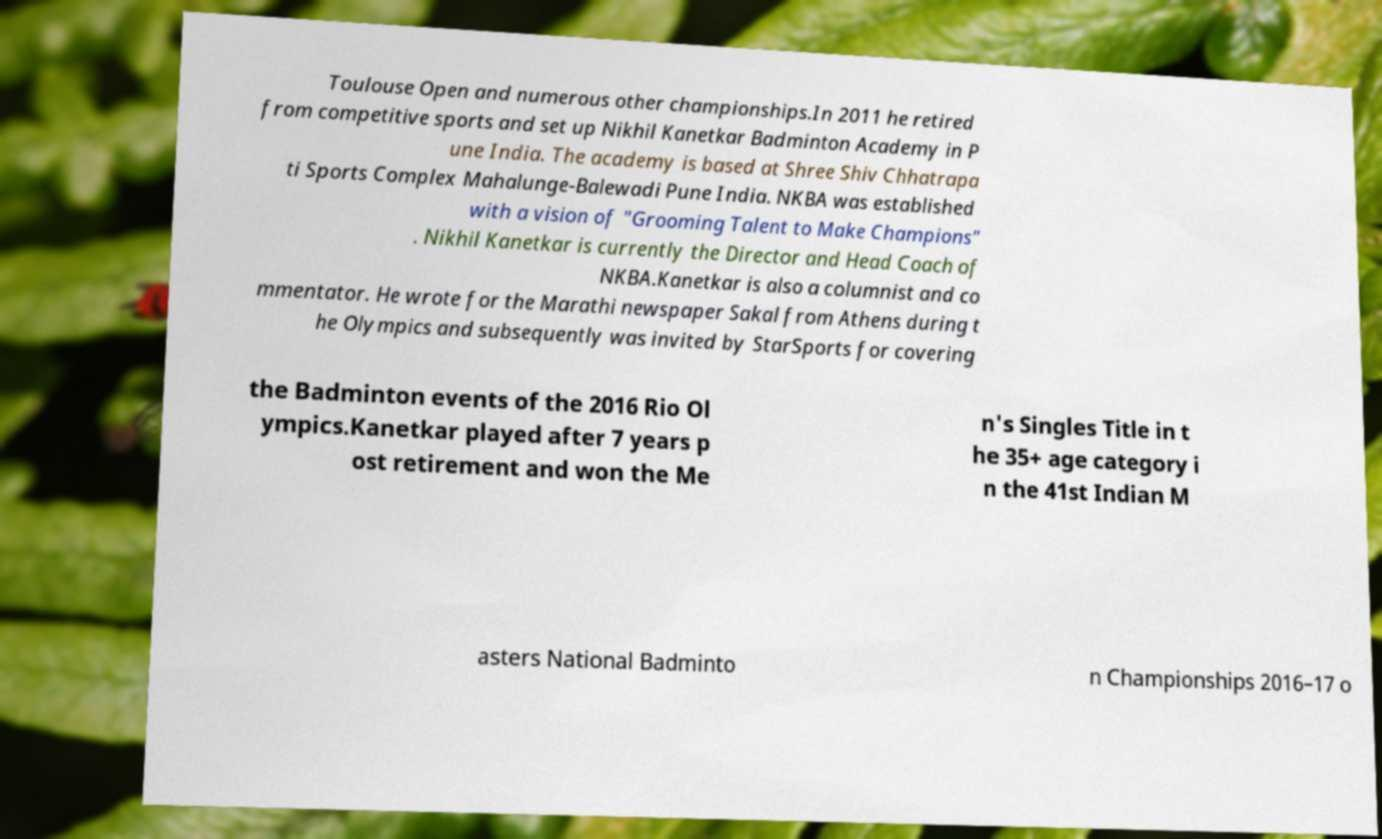Could you assist in decoding the text presented in this image and type it out clearly? Toulouse Open and numerous other championships.In 2011 he retired from competitive sports and set up Nikhil Kanetkar Badminton Academy in P une India. The academy is based at Shree Shiv Chhatrapa ti Sports Complex Mahalunge-Balewadi Pune India. NKBA was established with a vision of "Grooming Talent to Make Champions" . Nikhil Kanetkar is currently the Director and Head Coach of NKBA.Kanetkar is also a columnist and co mmentator. He wrote for the Marathi newspaper Sakal from Athens during t he Olympics and subsequently was invited by StarSports for covering the Badminton events of the 2016 Rio Ol ympics.Kanetkar played after 7 years p ost retirement and won the Me n's Singles Title in t he 35+ age category i n the 41st Indian M asters National Badminto n Championships 2016–17 o 